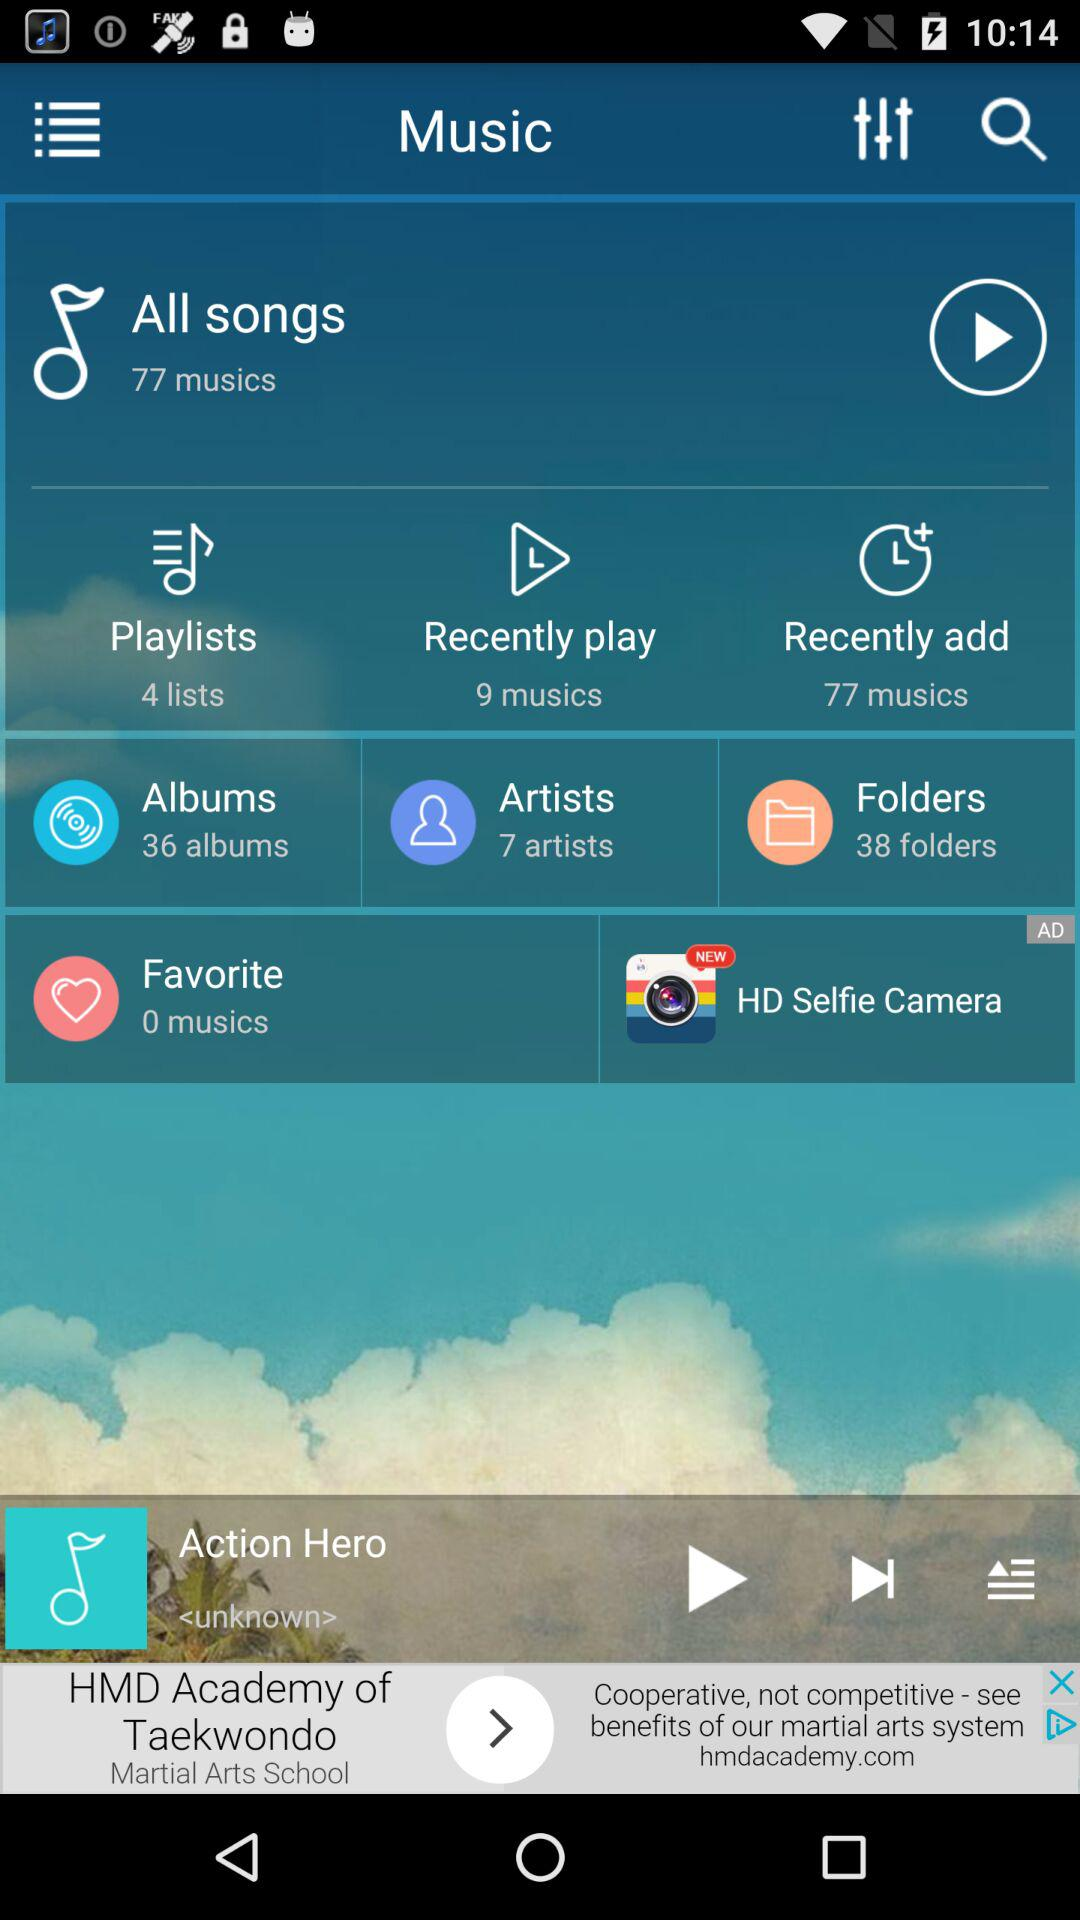How many albums are there? There are 36 albums. 